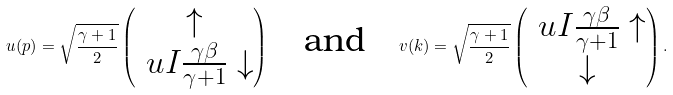<formula> <loc_0><loc_0><loc_500><loc_500>u ( p ) = \sqrt { \frac { \gamma + 1 } { 2 } } \begin{pmatrix} \uparrow \\ \ u I \frac { \gamma \beta } { \gamma + 1 } \downarrow \end{pmatrix} \quad \text {and} \quad v ( k ) = \sqrt { \frac { \gamma + 1 } { 2 } } \begin{pmatrix} \ u I \frac { \gamma \beta } { \gamma + 1 } \uparrow \\ \downarrow \end{pmatrix} .</formula> 